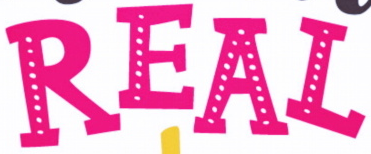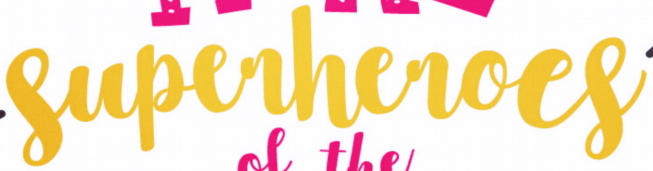What text is displayed in these images sequentially, separated by a semicolon? REAL; superheroes 